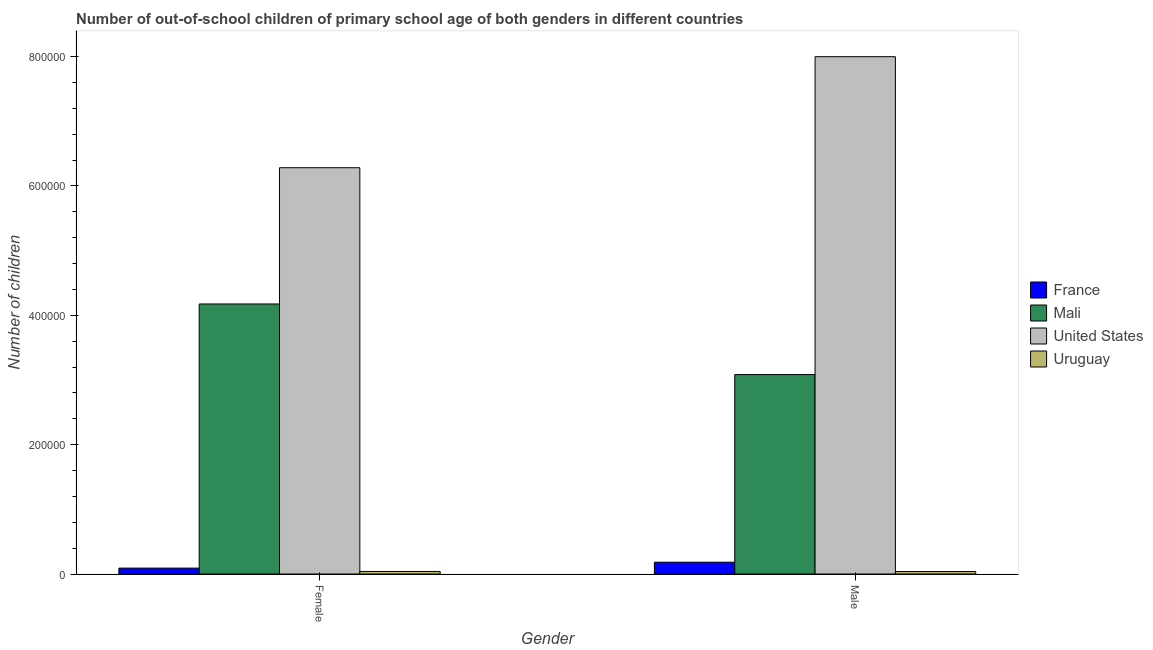Are the number of bars per tick equal to the number of legend labels?
Ensure brevity in your answer.  Yes. How many bars are there on the 1st tick from the left?
Make the answer very short. 4. What is the number of male out-of-school students in United States?
Give a very brief answer. 8.00e+05. Across all countries, what is the maximum number of female out-of-school students?
Offer a terse response. 6.28e+05. Across all countries, what is the minimum number of female out-of-school students?
Provide a short and direct response. 3964. In which country was the number of female out-of-school students maximum?
Provide a succinct answer. United States. In which country was the number of female out-of-school students minimum?
Your answer should be very brief. Uruguay. What is the total number of male out-of-school students in the graph?
Offer a very short reply. 1.13e+06. What is the difference between the number of female out-of-school students in United States and that in Uruguay?
Offer a terse response. 6.24e+05. What is the difference between the number of female out-of-school students in United States and the number of male out-of-school students in Mali?
Ensure brevity in your answer.  3.20e+05. What is the average number of male out-of-school students per country?
Your answer should be compact. 2.83e+05. What is the difference between the number of male out-of-school students and number of female out-of-school students in Uruguay?
Give a very brief answer. -149. In how many countries, is the number of female out-of-school students greater than 680000 ?
Provide a succinct answer. 0. What is the ratio of the number of female out-of-school students in United States to that in Uruguay?
Keep it short and to the point. 158.48. In how many countries, is the number of female out-of-school students greater than the average number of female out-of-school students taken over all countries?
Give a very brief answer. 2. What does the 2nd bar from the left in Female represents?
Provide a succinct answer. Mali. How many bars are there?
Give a very brief answer. 8. How many countries are there in the graph?
Provide a succinct answer. 4. Does the graph contain any zero values?
Your answer should be very brief. No. Does the graph contain grids?
Give a very brief answer. No. Where does the legend appear in the graph?
Your answer should be compact. Center right. How are the legend labels stacked?
Your answer should be very brief. Vertical. What is the title of the graph?
Offer a terse response. Number of out-of-school children of primary school age of both genders in different countries. What is the label or title of the X-axis?
Provide a succinct answer. Gender. What is the label or title of the Y-axis?
Offer a terse response. Number of children. What is the Number of children in France in Female?
Provide a succinct answer. 9097. What is the Number of children of Mali in Female?
Your answer should be compact. 4.18e+05. What is the Number of children of United States in Female?
Make the answer very short. 6.28e+05. What is the Number of children in Uruguay in Female?
Provide a succinct answer. 3964. What is the Number of children of France in Male?
Ensure brevity in your answer.  1.82e+04. What is the Number of children in Mali in Male?
Your response must be concise. 3.08e+05. What is the Number of children of United States in Male?
Your answer should be very brief. 8.00e+05. What is the Number of children of Uruguay in Male?
Offer a very short reply. 3815. Across all Gender, what is the maximum Number of children of France?
Offer a very short reply. 1.82e+04. Across all Gender, what is the maximum Number of children of Mali?
Your answer should be compact. 4.18e+05. Across all Gender, what is the maximum Number of children of United States?
Keep it short and to the point. 8.00e+05. Across all Gender, what is the maximum Number of children of Uruguay?
Your answer should be compact. 3964. Across all Gender, what is the minimum Number of children of France?
Provide a short and direct response. 9097. Across all Gender, what is the minimum Number of children in Mali?
Your answer should be very brief. 3.08e+05. Across all Gender, what is the minimum Number of children of United States?
Provide a short and direct response. 6.28e+05. Across all Gender, what is the minimum Number of children in Uruguay?
Provide a short and direct response. 3815. What is the total Number of children of France in the graph?
Provide a short and direct response. 2.73e+04. What is the total Number of children in Mali in the graph?
Provide a short and direct response. 7.26e+05. What is the total Number of children of United States in the graph?
Make the answer very short. 1.43e+06. What is the total Number of children of Uruguay in the graph?
Your answer should be compact. 7779. What is the difference between the Number of children of France in Female and that in Male?
Provide a short and direct response. -9134. What is the difference between the Number of children of Mali in Female and that in Male?
Ensure brevity in your answer.  1.09e+05. What is the difference between the Number of children of United States in Female and that in Male?
Your answer should be compact. -1.72e+05. What is the difference between the Number of children in Uruguay in Female and that in Male?
Your answer should be compact. 149. What is the difference between the Number of children in France in Female and the Number of children in Mali in Male?
Offer a terse response. -2.99e+05. What is the difference between the Number of children in France in Female and the Number of children in United States in Male?
Offer a very short reply. -7.91e+05. What is the difference between the Number of children of France in Female and the Number of children of Uruguay in Male?
Make the answer very short. 5282. What is the difference between the Number of children of Mali in Female and the Number of children of United States in Male?
Your answer should be very brief. -3.82e+05. What is the difference between the Number of children of Mali in Female and the Number of children of Uruguay in Male?
Ensure brevity in your answer.  4.14e+05. What is the difference between the Number of children in United States in Female and the Number of children in Uruguay in Male?
Your response must be concise. 6.24e+05. What is the average Number of children in France per Gender?
Ensure brevity in your answer.  1.37e+04. What is the average Number of children in Mali per Gender?
Give a very brief answer. 3.63e+05. What is the average Number of children of United States per Gender?
Your answer should be compact. 7.14e+05. What is the average Number of children in Uruguay per Gender?
Offer a very short reply. 3889.5. What is the difference between the Number of children in France and Number of children in Mali in Female?
Keep it short and to the point. -4.08e+05. What is the difference between the Number of children in France and Number of children in United States in Female?
Your response must be concise. -6.19e+05. What is the difference between the Number of children in France and Number of children in Uruguay in Female?
Make the answer very short. 5133. What is the difference between the Number of children in Mali and Number of children in United States in Female?
Make the answer very short. -2.11e+05. What is the difference between the Number of children in Mali and Number of children in Uruguay in Female?
Offer a terse response. 4.14e+05. What is the difference between the Number of children in United States and Number of children in Uruguay in Female?
Offer a very short reply. 6.24e+05. What is the difference between the Number of children of France and Number of children of Mali in Male?
Your response must be concise. -2.90e+05. What is the difference between the Number of children of France and Number of children of United States in Male?
Provide a succinct answer. -7.82e+05. What is the difference between the Number of children in France and Number of children in Uruguay in Male?
Ensure brevity in your answer.  1.44e+04. What is the difference between the Number of children of Mali and Number of children of United States in Male?
Provide a succinct answer. -4.92e+05. What is the difference between the Number of children of Mali and Number of children of Uruguay in Male?
Keep it short and to the point. 3.05e+05. What is the difference between the Number of children in United States and Number of children in Uruguay in Male?
Offer a very short reply. 7.96e+05. What is the ratio of the Number of children in France in Female to that in Male?
Offer a terse response. 0.5. What is the ratio of the Number of children in Mali in Female to that in Male?
Ensure brevity in your answer.  1.35. What is the ratio of the Number of children of United States in Female to that in Male?
Make the answer very short. 0.79. What is the ratio of the Number of children in Uruguay in Female to that in Male?
Provide a short and direct response. 1.04. What is the difference between the highest and the second highest Number of children in France?
Provide a short and direct response. 9134. What is the difference between the highest and the second highest Number of children of Mali?
Offer a very short reply. 1.09e+05. What is the difference between the highest and the second highest Number of children in United States?
Your response must be concise. 1.72e+05. What is the difference between the highest and the second highest Number of children of Uruguay?
Give a very brief answer. 149. What is the difference between the highest and the lowest Number of children in France?
Provide a succinct answer. 9134. What is the difference between the highest and the lowest Number of children of Mali?
Keep it short and to the point. 1.09e+05. What is the difference between the highest and the lowest Number of children of United States?
Keep it short and to the point. 1.72e+05. What is the difference between the highest and the lowest Number of children in Uruguay?
Provide a succinct answer. 149. 